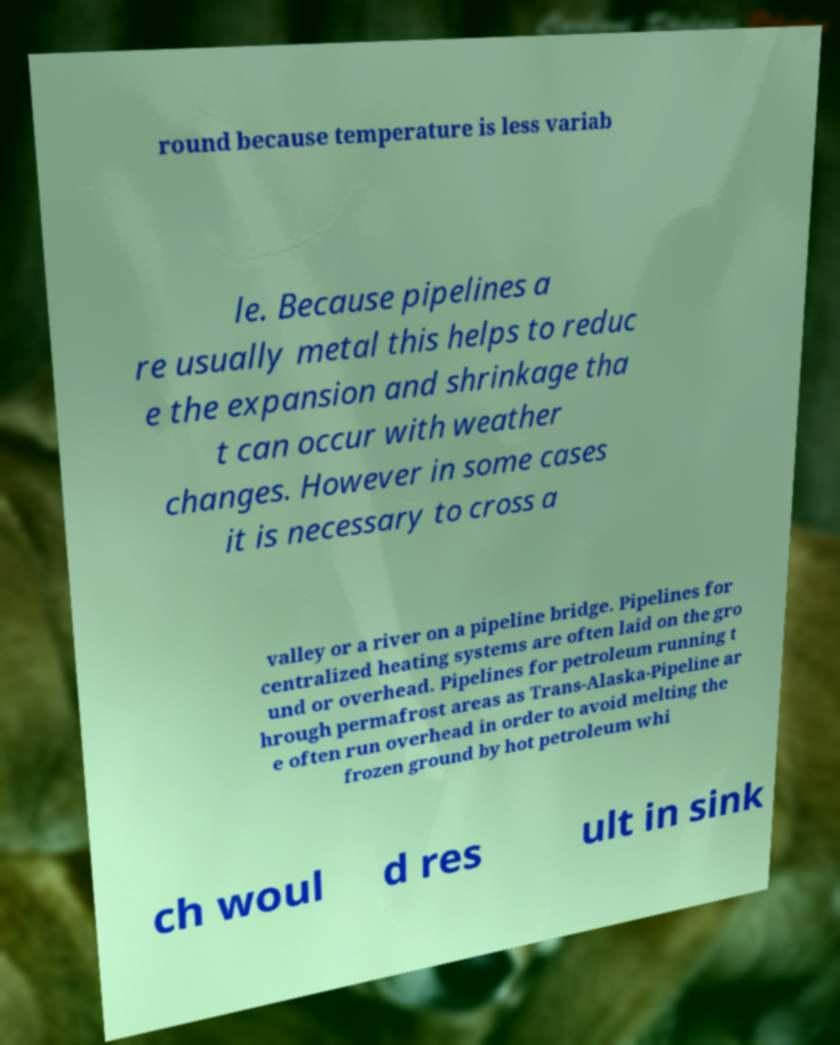Could you assist in decoding the text presented in this image and type it out clearly? round because temperature is less variab le. Because pipelines a re usually metal this helps to reduc e the expansion and shrinkage tha t can occur with weather changes. However in some cases it is necessary to cross a valley or a river on a pipeline bridge. Pipelines for centralized heating systems are often laid on the gro und or overhead. Pipelines for petroleum running t hrough permafrost areas as Trans-Alaska-Pipeline ar e often run overhead in order to avoid melting the frozen ground by hot petroleum whi ch woul d res ult in sink 